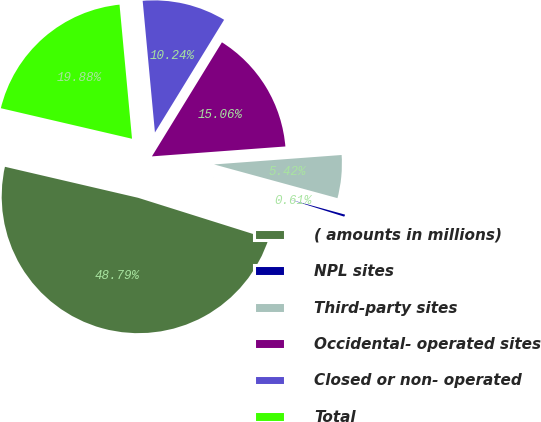Convert chart. <chart><loc_0><loc_0><loc_500><loc_500><pie_chart><fcel>( amounts in millions)<fcel>NPL sites<fcel>Third-party sites<fcel>Occidental- operated sites<fcel>Closed or non- operated<fcel>Total<nl><fcel>48.79%<fcel>0.61%<fcel>5.42%<fcel>15.06%<fcel>10.24%<fcel>19.88%<nl></chart> 